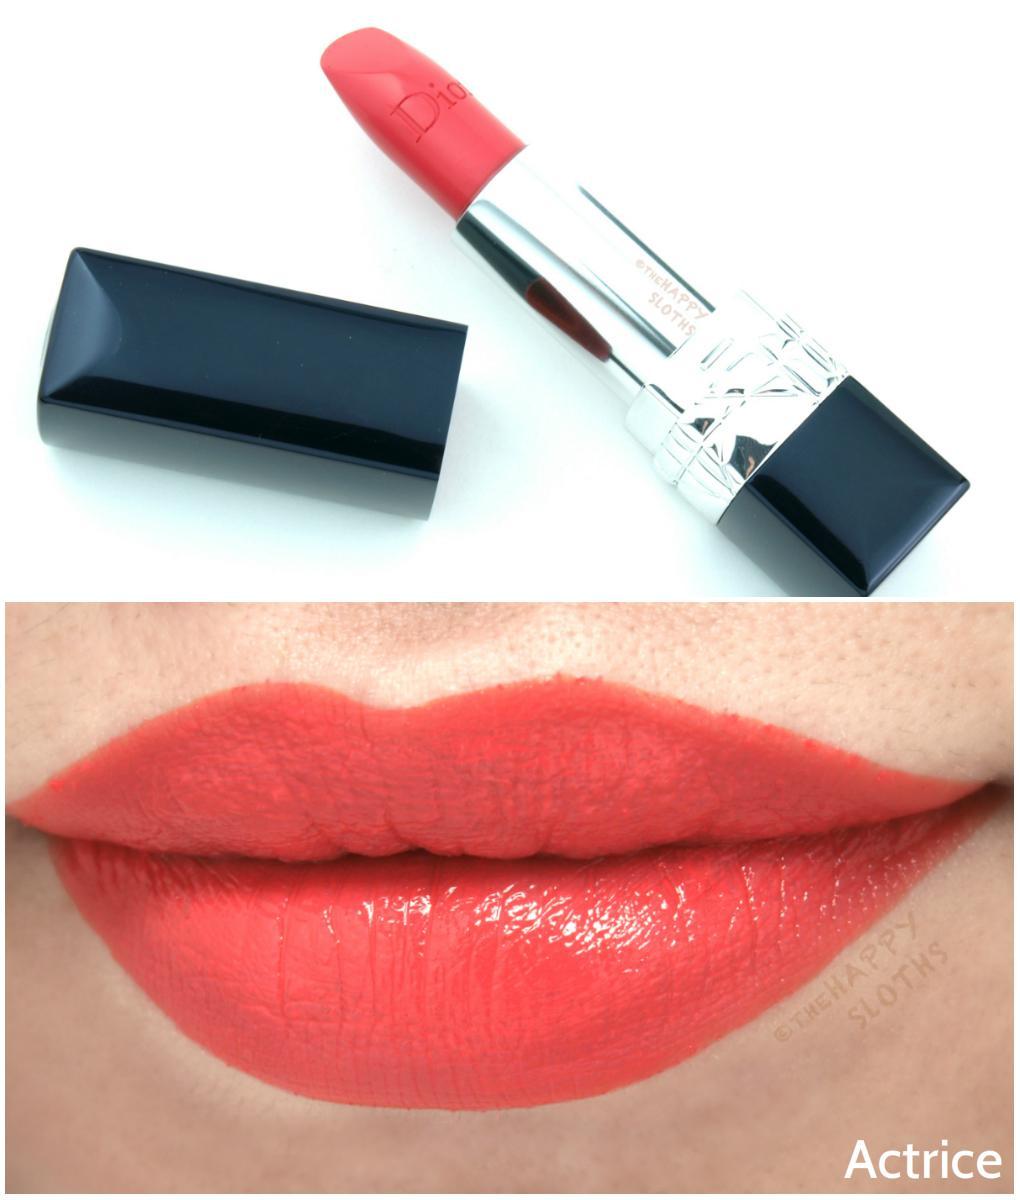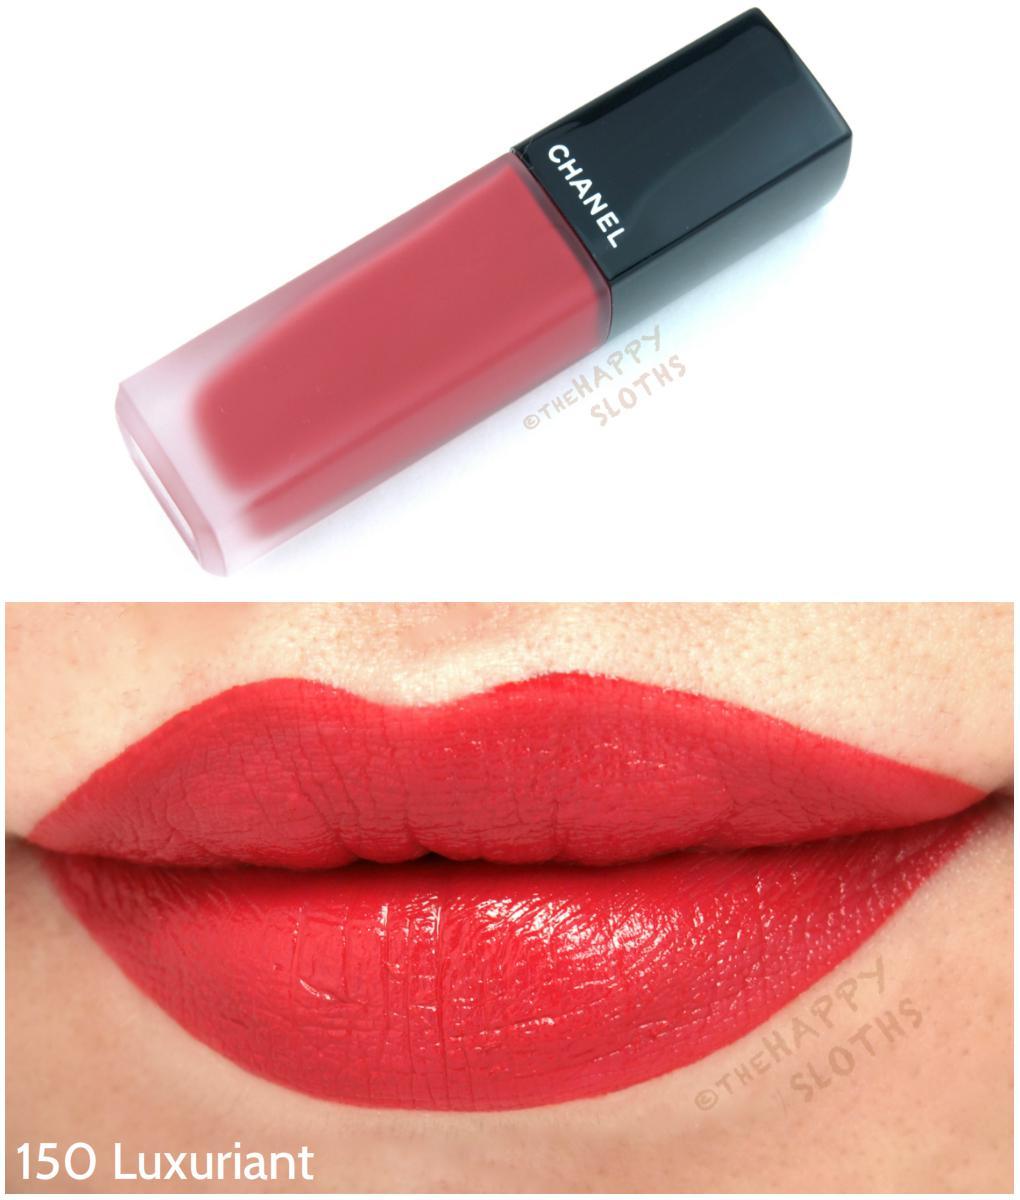The first image is the image on the left, the second image is the image on the right. Assess this claim about the two images: "The left image contains a lidded slender lip makeup over a pair of lips, while the right image shows an uncapped tube lipstick over a pair of lips.". Correct or not? Answer yes or no. No. The first image is the image on the left, the second image is the image on the right. Given the left and right images, does the statement "The lip stick in the right image is uncapped." hold true? Answer yes or no. No. 